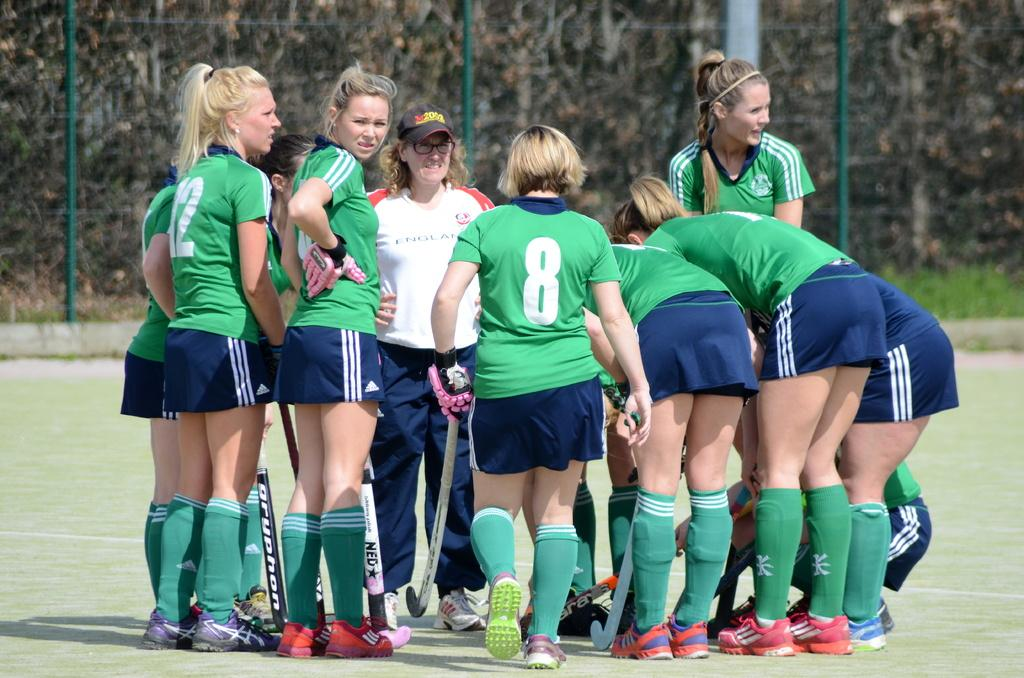<image>
Create a compact narrative representing the image presented. A team of female field hockey player huddle together as no 8 joins to them. 